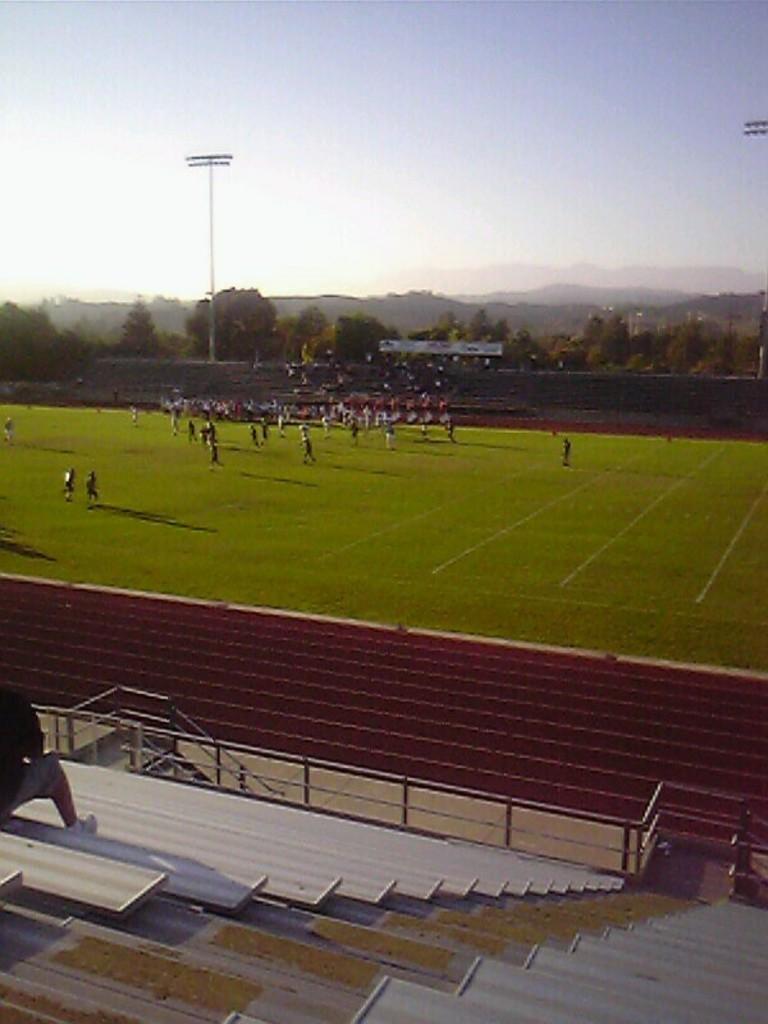How would you summarize this image in a sentence or two? In this picture we can see some people standing here, there is grass here, on the left side there is a person sitting here, we can see stairs here, there is a pole here, we can see some trees in the background, there is sky at the top of the picture. 